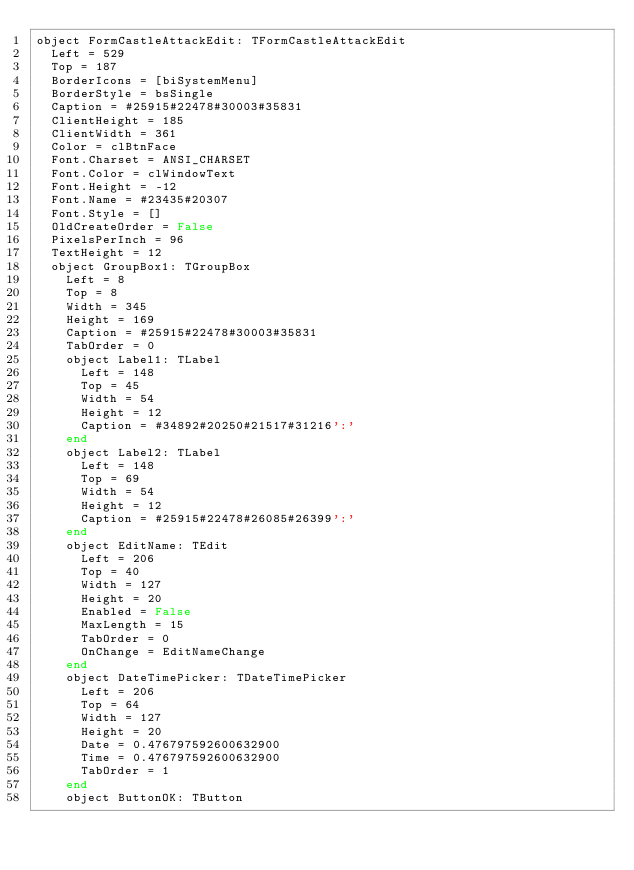Convert code to text. <code><loc_0><loc_0><loc_500><loc_500><_Pascal_>object FormCastleAttackEdit: TFormCastleAttackEdit
  Left = 529
  Top = 187
  BorderIcons = [biSystemMenu]
  BorderStyle = bsSingle
  Caption = #25915#22478#30003#35831
  ClientHeight = 185
  ClientWidth = 361
  Color = clBtnFace
  Font.Charset = ANSI_CHARSET
  Font.Color = clWindowText
  Font.Height = -12
  Font.Name = #23435#20307
  Font.Style = []
  OldCreateOrder = False
  PixelsPerInch = 96
  TextHeight = 12
  object GroupBox1: TGroupBox
    Left = 8
    Top = 8
    Width = 345
    Height = 169
    Caption = #25915#22478#30003#35831
    TabOrder = 0
    object Label1: TLabel
      Left = 148
      Top = 45
      Width = 54
      Height = 12
      Caption = #34892#20250#21517#31216':'
    end
    object Label2: TLabel
      Left = 148
      Top = 69
      Width = 54
      Height = 12
      Caption = #25915#22478#26085#26399':'
    end
    object EditName: TEdit
      Left = 206
      Top = 40
      Width = 127
      Height = 20
      Enabled = False
      MaxLength = 15
      TabOrder = 0
      OnChange = EditNameChange
    end
    object DateTimePicker: TDateTimePicker
      Left = 206
      Top = 64
      Width = 127
      Height = 20
      Date = 0.476797592600632900
      Time = 0.476797592600632900
      TabOrder = 1
    end
    object ButtonOK: TButton</code> 